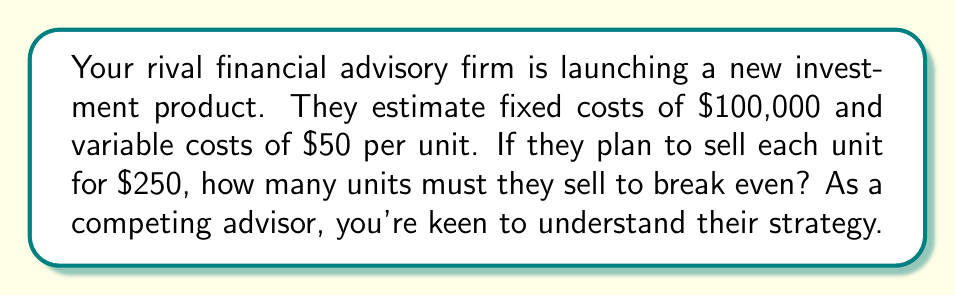Could you help me with this problem? Let's approach this step-by-step:

1) First, let's define our variables:
   $x$ = number of units sold
   $F$ = fixed costs
   $v$ = variable cost per unit
   $p$ = price per unit

2) We know:
   $F = \$100,000$
   $v = \$50$ per unit
   $p = \$250$ per unit

3) The break-even point occurs when total revenue equals total costs:
   $\text{Total Revenue} = \text{Total Costs}$
   $px = F + vx$

4) Let's substitute our known values:
   $250x = 100,000 + 50x$

5) Now, let's solve for $x$:
   $250x - 50x = 100,000$
   $200x = 100,000$

6) Divide both sides by 200:
   $x = \frac{100,000}{200} = 500$

Therefore, your rival firm needs to sell 500 units to break even.
Answer: 500 units 